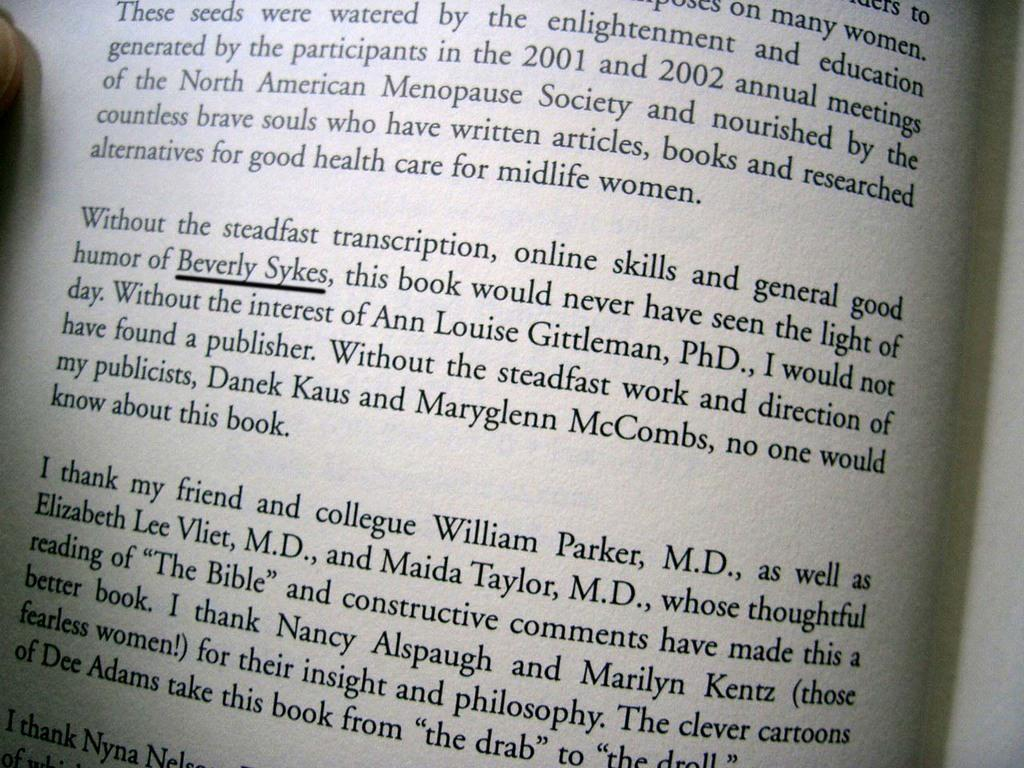<image>
Give a short and clear explanation of the subsequent image. A partial page of a book is shown with the name Beverly Sykes underlined. 